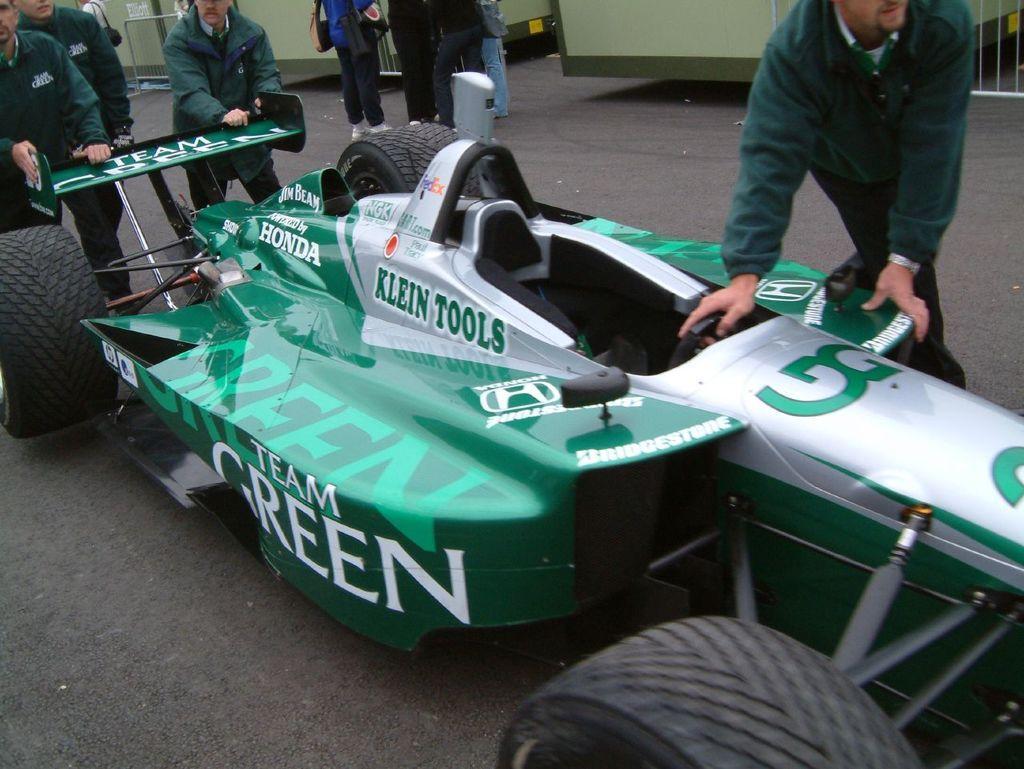How would you summarize this image in a sentence or two? There is a sports car in the center of the image and there are people around it. There are people, barricade, it seems like containers in the background area. 